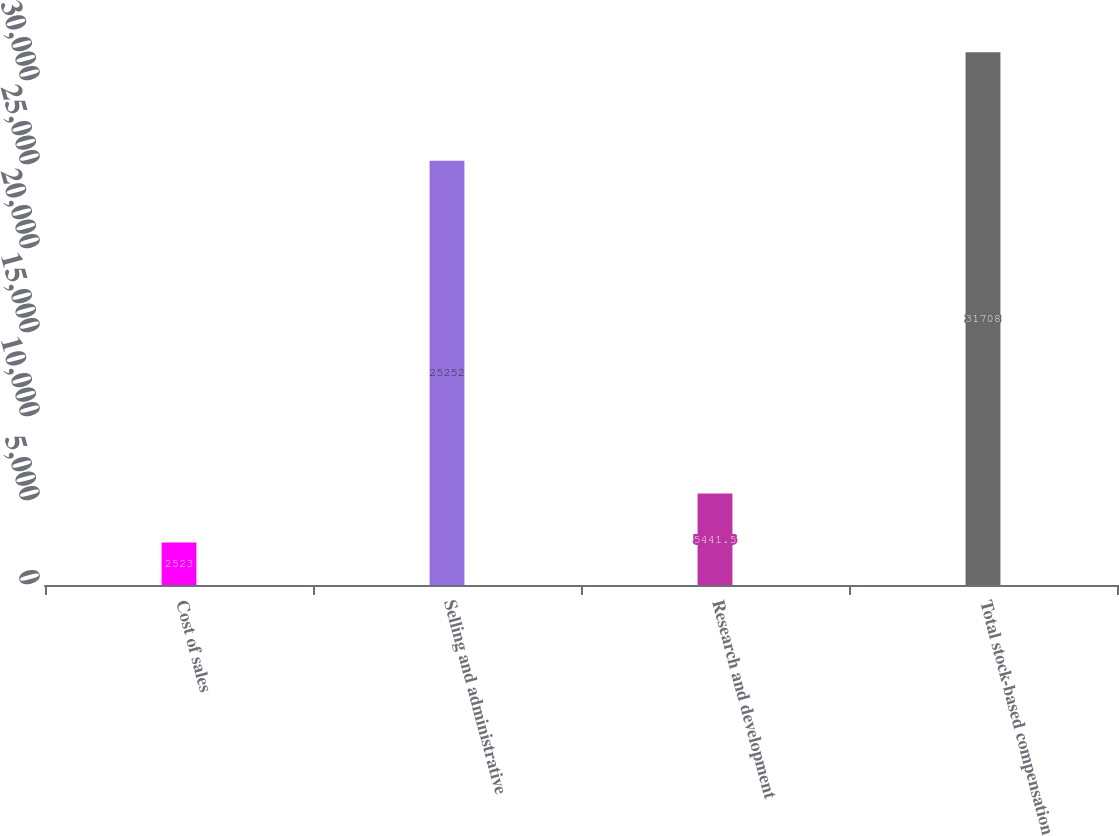<chart> <loc_0><loc_0><loc_500><loc_500><bar_chart><fcel>Cost of sales<fcel>Selling and administrative<fcel>Research and development<fcel>Total stock-based compensation<nl><fcel>2523<fcel>25252<fcel>5441.5<fcel>31708<nl></chart> 